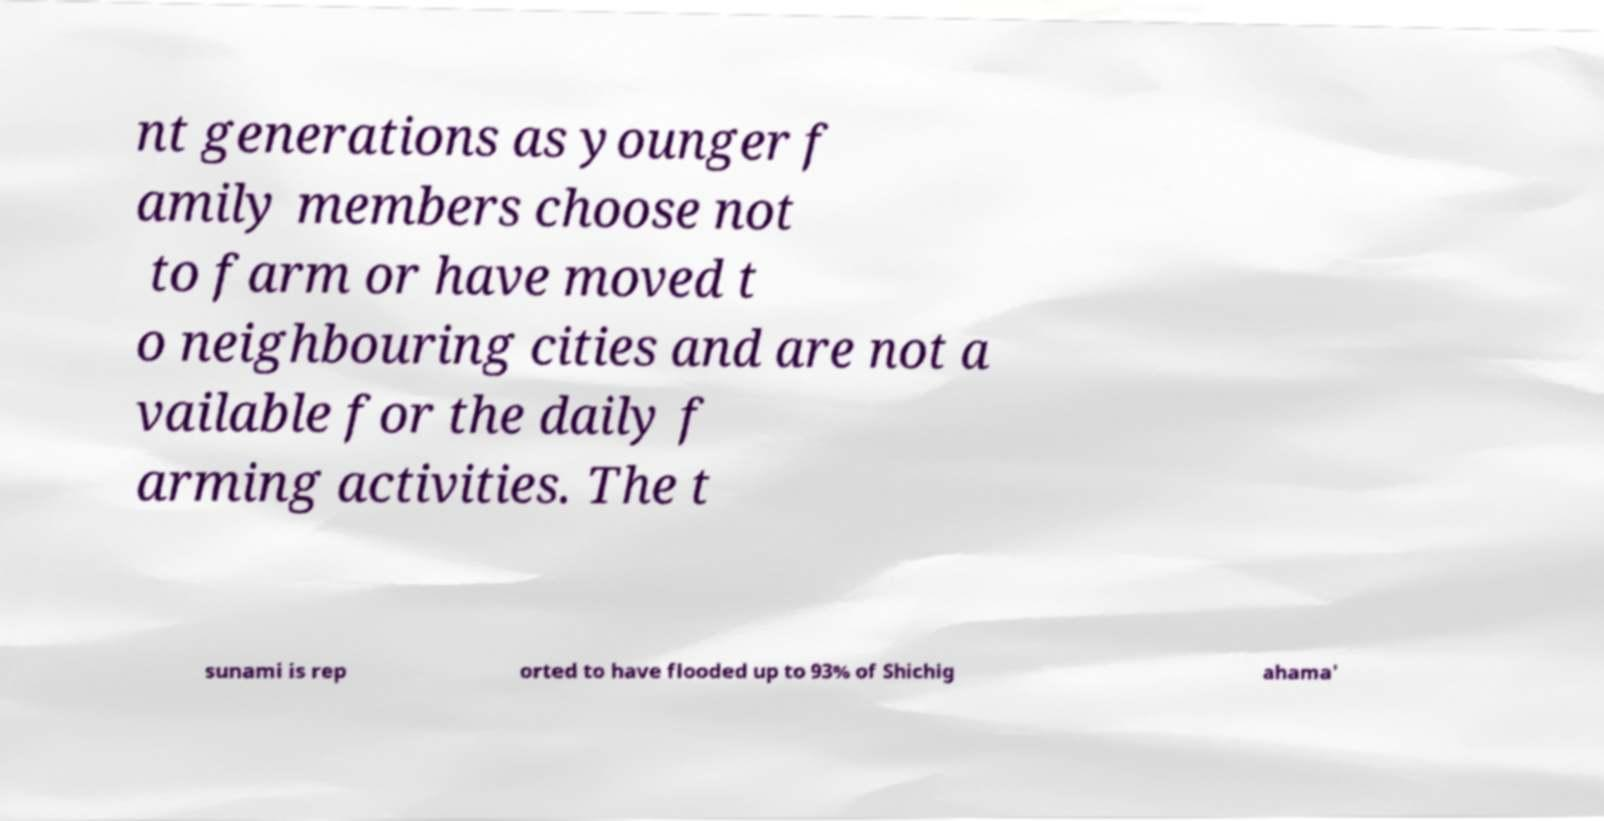There's text embedded in this image that I need extracted. Can you transcribe it verbatim? nt generations as younger f amily members choose not to farm or have moved t o neighbouring cities and are not a vailable for the daily f arming activities. The t sunami is rep orted to have flooded up to 93% of Shichig ahama' 